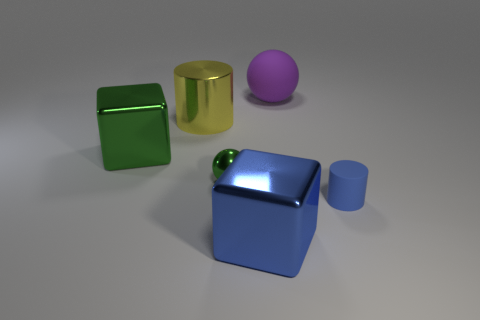Add 3 blue rubber cylinders. How many objects exist? 9 Subtract all blue cylinders. How many cylinders are left? 1 Subtract all balls. How many objects are left? 4 Add 4 yellow cylinders. How many yellow cylinders are left? 5 Add 2 small spheres. How many small spheres exist? 3 Subtract 0 red cylinders. How many objects are left? 6 Subtract 2 blocks. How many blocks are left? 0 Subtract all purple cylinders. Subtract all yellow balls. How many cylinders are left? 2 Subtract all yellow spheres. How many green cylinders are left? 0 Subtract all big cylinders. Subtract all shiny cylinders. How many objects are left? 4 